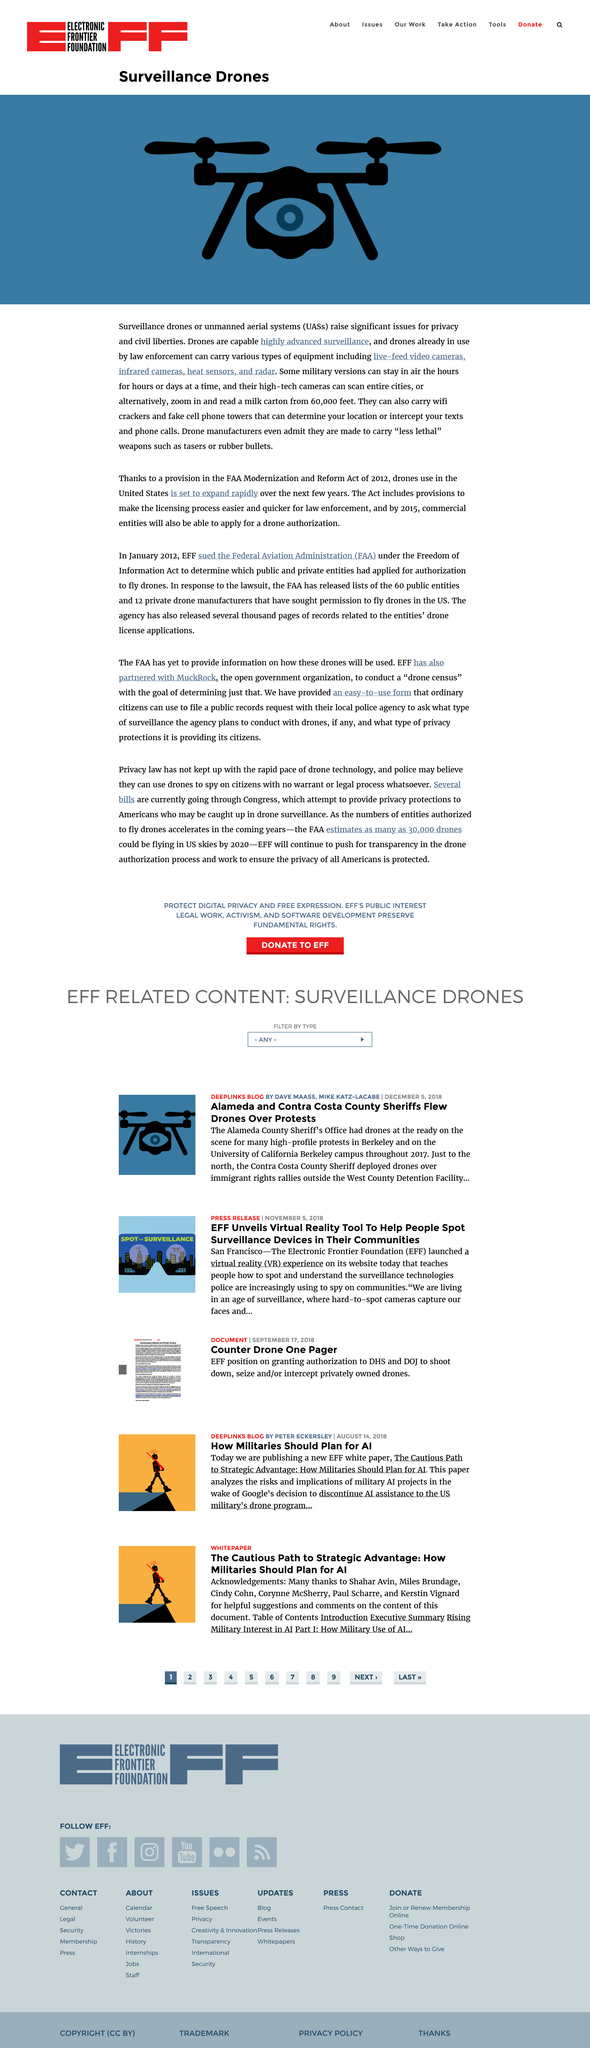Give some essential details in this illustration. The image in question is a surveillance drone. Surveillance drones raise significant issues related to privacy and civil liberties, as they can potentially infringe upon individuals' right to privacy and autonomy. Drones used by law enforcement can carry a variety of equipment, including live-feed video cameras, infrared cameras, heat sensors, and radar. 